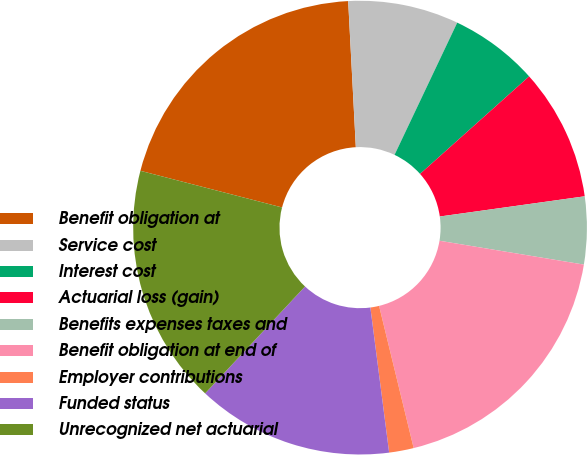<chart> <loc_0><loc_0><loc_500><loc_500><pie_chart><fcel>Benefit obligation at<fcel>Service cost<fcel>Interest cost<fcel>Actuarial loss (gain)<fcel>Benefits expenses taxes and<fcel>Benefit obligation at end of<fcel>Employer contributions<fcel>Funded status<fcel>Unrecognized net actuarial<nl><fcel>20.14%<fcel>7.88%<fcel>6.34%<fcel>9.41%<fcel>4.81%<fcel>18.6%<fcel>1.75%<fcel>14.01%<fcel>17.07%<nl></chart> 